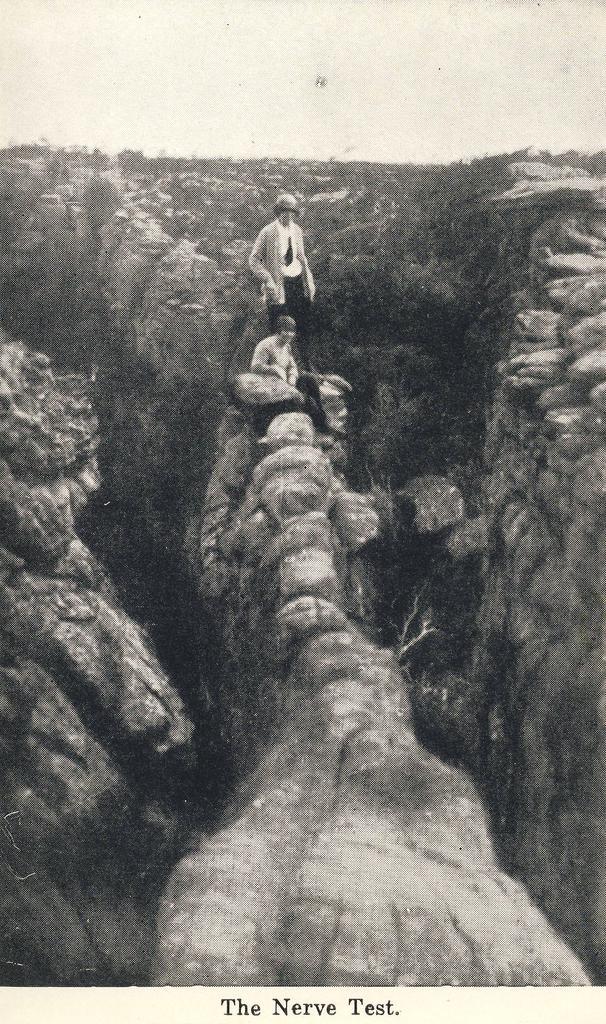Please provide a concise description of this image. It is an old image,there are lot of hills and rocks,on one of the hill a man is sitting and behind him another person is standing. 